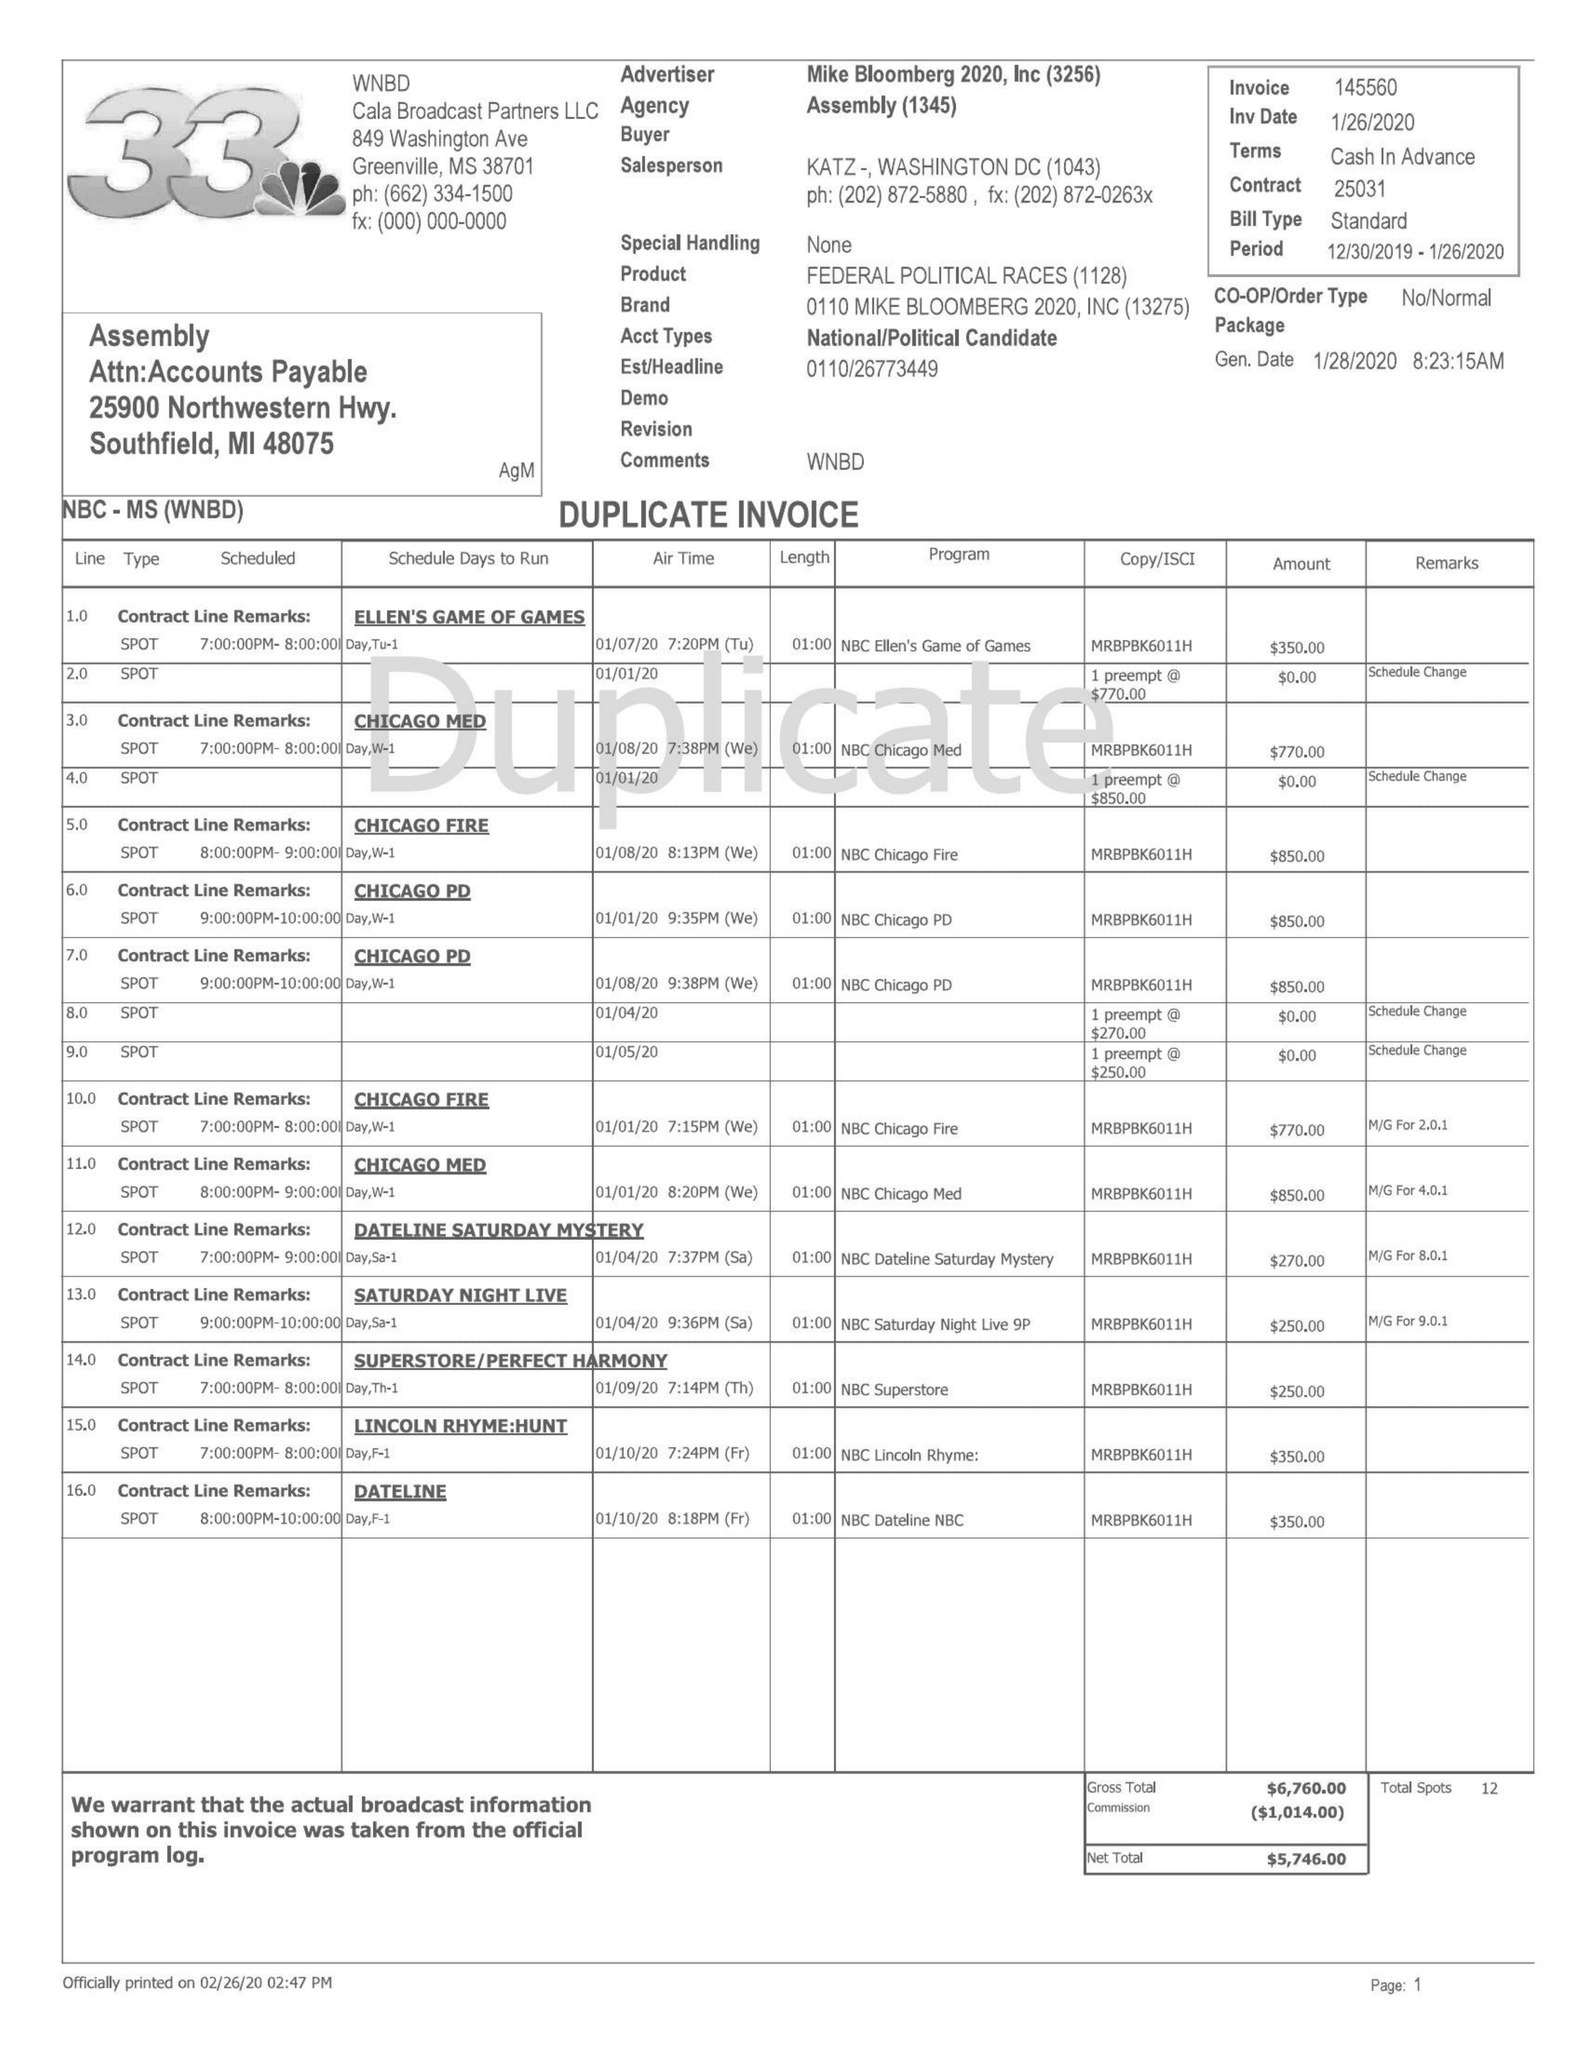What is the value for the contract_num?
Answer the question using a single word or phrase. 25031 